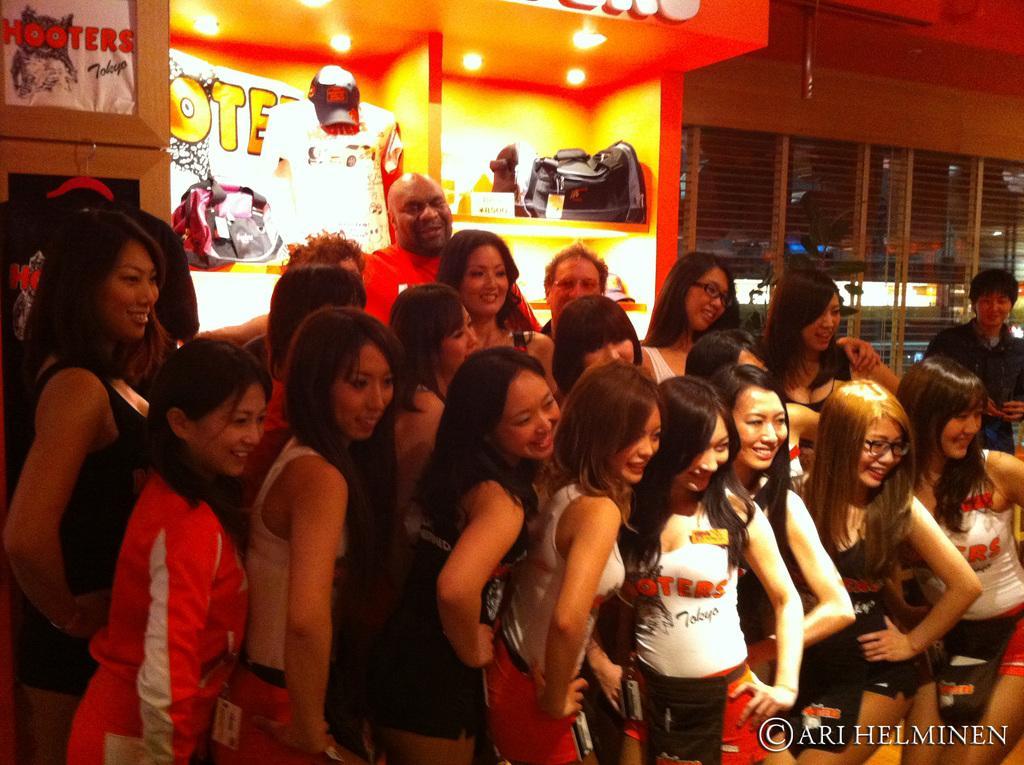In one or two sentences, can you explain what this image depicts? In this image I can see a group of people standing and posing for the picture. I can see some shelves behind them I can see some caps, bags, a T-shirt on the shelves. I can see a building behind them. I can see another person standing on the right hand side of the image In the right bottom corner I can see some text. 